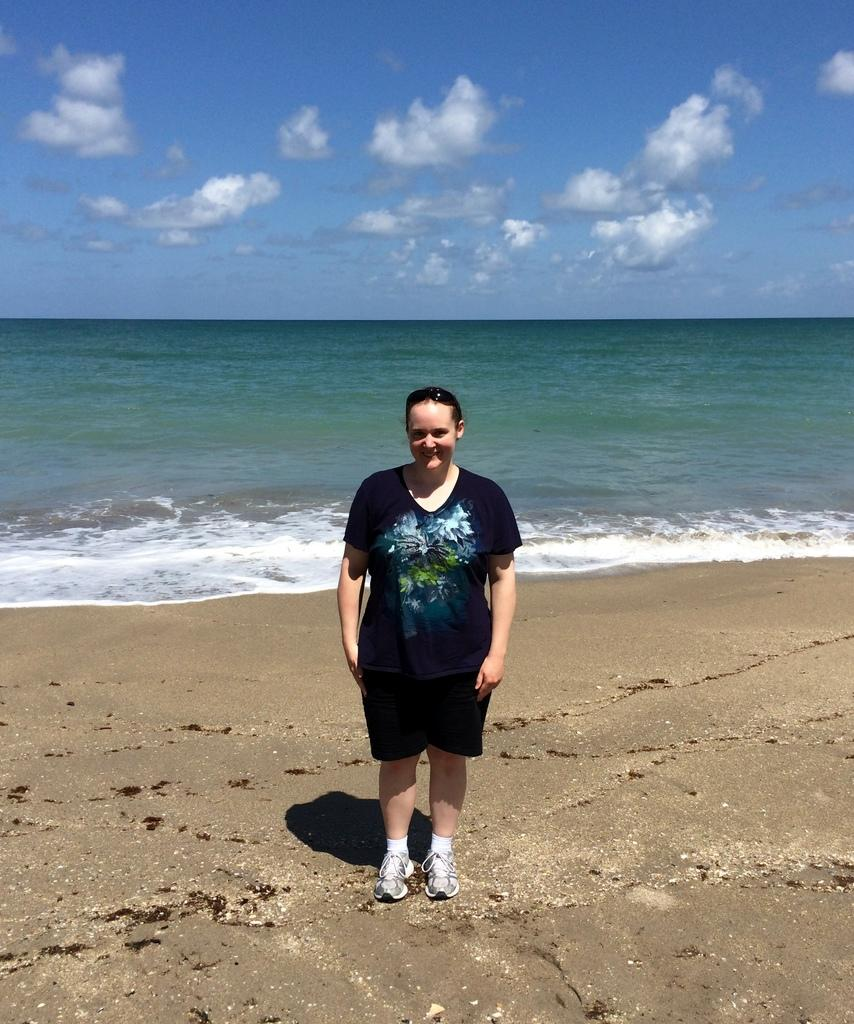What is the main subject of the image? There is a person standing in the image. Where is the person located? The person is at the beach. What is the person wearing? The person is wearing clothes. What can be seen in the sky? There are clouds in the sky. How many birds are in the flock flying over the person in the image? There are no birds or flock visible in the image. Are there any police officers present in the image? There is no mention of police officers in the provided facts, and therefore no such presence can be confirmed. 